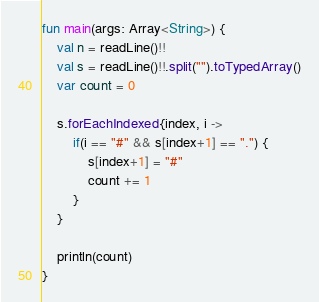<code> <loc_0><loc_0><loc_500><loc_500><_Kotlin_>fun main(args: Array<String>) {
    val n = readLine()!!
    val s = readLine()!!.split("").toTypedArray()
    var count = 0

    s.forEachIndexed{index, i ->
        if(i == "#" && s[index+1] == ".") {
            s[index+1] = "#"
            count += 1
        }
    }

    println(count)
}
</code> 